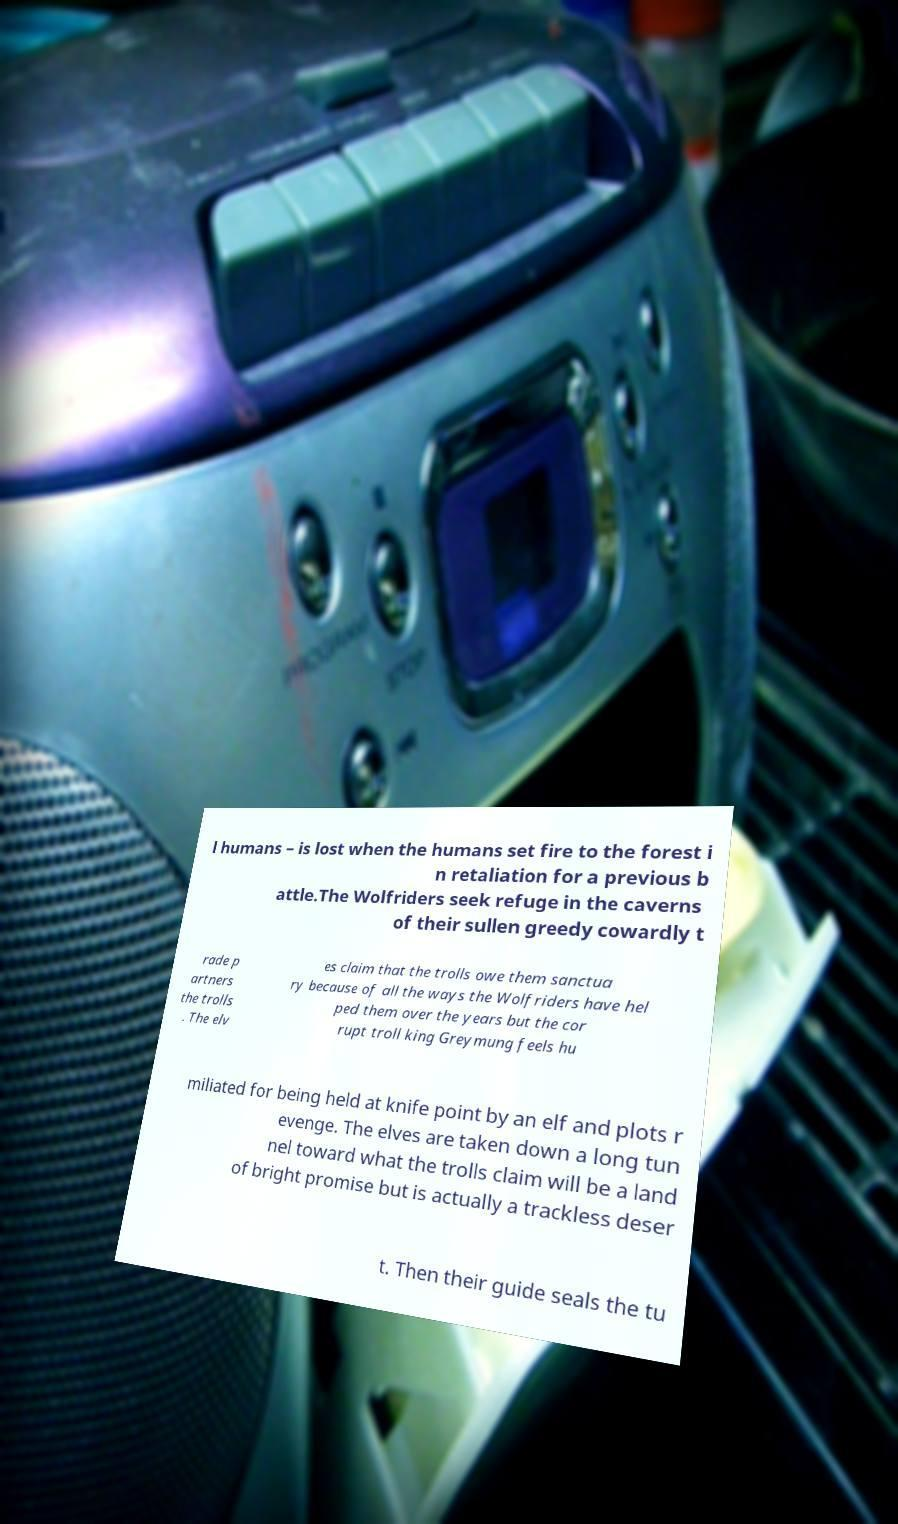Please identify and transcribe the text found in this image. l humans – is lost when the humans set fire to the forest i n retaliation for a previous b attle.The Wolfriders seek refuge in the caverns of their sullen greedy cowardly t rade p artners the trolls . The elv es claim that the trolls owe them sanctua ry because of all the ways the Wolfriders have hel ped them over the years but the cor rupt troll king Greymung feels hu miliated for being held at knife point by an elf and plots r evenge. The elves are taken down a long tun nel toward what the trolls claim will be a land of bright promise but is actually a trackless deser t. Then their guide seals the tu 